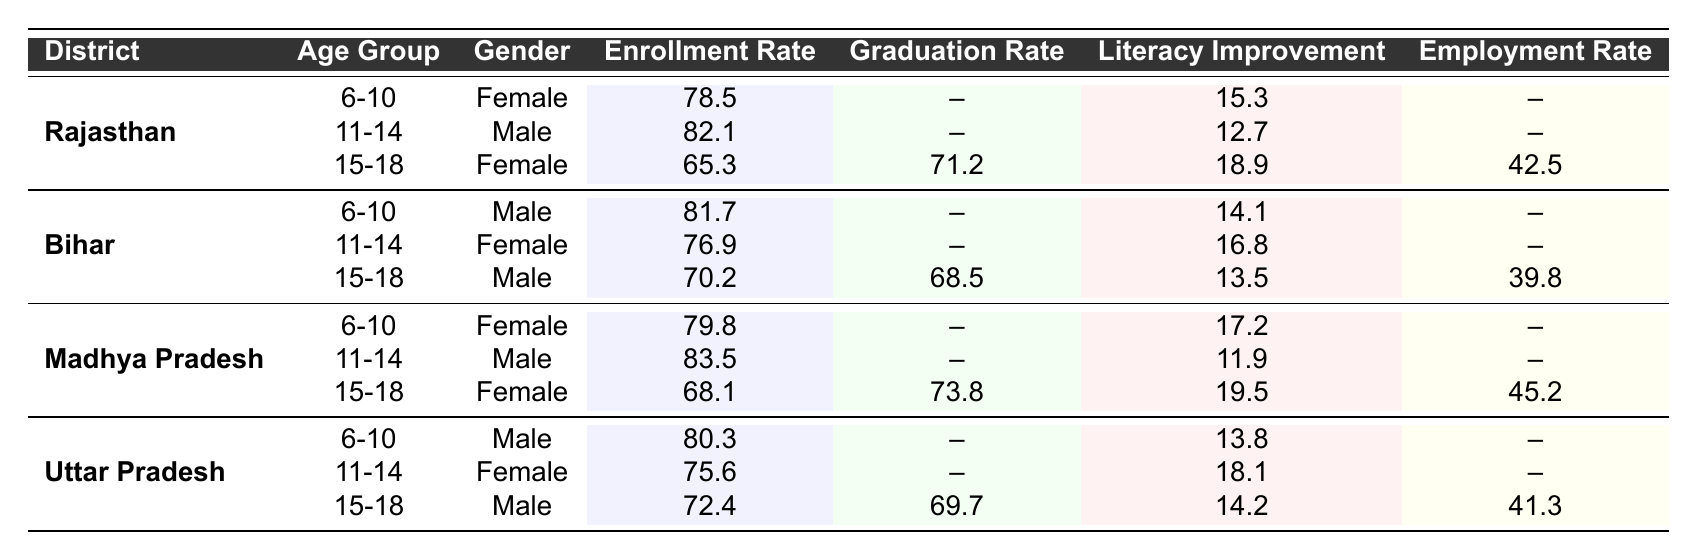What is the enrollment rate for females aged 6-10 in Rajasthan? The table shows the enrollment rate for females aged 6-10 in Rajasthan is 78.5%.
Answer: 78.5% Which gender has a higher enrollment rate among the 15-18 age group in Bihar? In Bihar, the enrollment rate for males aged 15-18 is 70.2%, while for females it is not available. Therefore, we cannot determine which gender has a higher enrollment rate for this age group.
Answer: Cannot determine What is the graduation rate for males aged 15-18 in Uttar Pradesh? The table states that the graduation rate for males aged 15-18 in Uttar Pradesh is 69.7%.
Answer: 69.7% What is the average literacy improvement for the 15-18 age group across all districts? The literacy improvements for the 15-18 age group across all districts are 18.9, 13.5, 19.5, and 14.2. Adding these gives 66.1, and dividing by 4 (the number of data points) gives an average of 16.525.
Answer: 16.525 Which age group in Madhya Pradesh shows the highest literacy improvement? In Madhya Pradesh, the literacy improvements for different age groups are 17.2 for 6-10, 11.9 for 11-14, and 19.5 for 15-18. The highest improvement is 19.5, which is for the 15-18 age group.
Answer: 15-18 Is there a graduation rate reported for any district in the 11-14 age group? The data shows that there are no graduation rates reported for any district in the 11-14 age group, as indicated by the '--' values.
Answer: No What is the overall employment rate for females aged 15-18 in Rajasthan? The employment rate for females aged 15-18 in Rajasthan is 42.5%. Therefore, the overall rate is just 42.5%, as it's the only value represented.
Answer: 42.5% Do males aged 11-14 in any district exhibit an enrollment rate lower than 75%? The enrollment rates for males aged 11-14 in all districts are 82.1 (Rajasthan), 76.9 (Bihar), 83.5 (Madhya Pradesh), and none are lower than 75%.
Answer: No What district has the lowest literacy improvement for the 15-18 age group? The literacy improvements for the 15-18 age group for each district are 18.9 (Rajasthan), 13.5 (Bihar), 19.5 (Madhya Pradesh), and 14.2 (Uttar Pradesh). The lowest is 13.5, which belongs to Bihar.
Answer: Bihar Find the difference in enrollment rate for males aged 15-18 between Bihar and Uttar Pradesh. The enrollment rates are 70.2 in Bihar and 72.4 in Uttar Pradesh. The difference is calculated as 72.4 - 70.2 = 2.2.
Answer: 2.2 